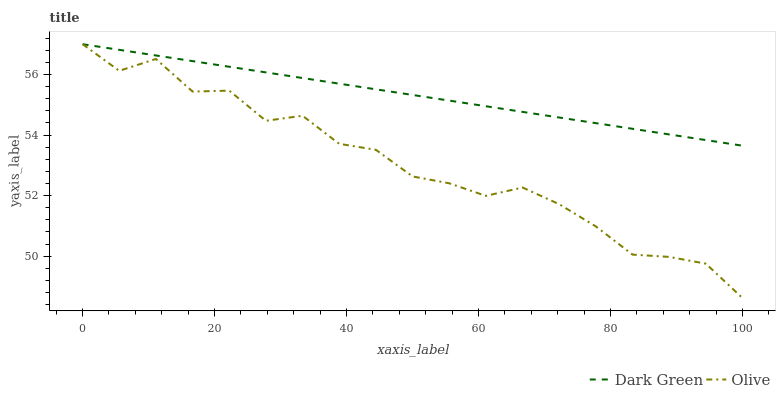Does Olive have the minimum area under the curve?
Answer yes or no. Yes. Does Dark Green have the maximum area under the curve?
Answer yes or no. Yes. Does Dark Green have the minimum area under the curve?
Answer yes or no. No. Is Dark Green the smoothest?
Answer yes or no. Yes. Is Olive the roughest?
Answer yes or no. Yes. Is Dark Green the roughest?
Answer yes or no. No. Does Olive have the lowest value?
Answer yes or no. Yes. Does Dark Green have the lowest value?
Answer yes or no. No. Does Dark Green have the highest value?
Answer yes or no. Yes. Does Dark Green intersect Olive?
Answer yes or no. Yes. Is Dark Green less than Olive?
Answer yes or no. No. Is Dark Green greater than Olive?
Answer yes or no. No. 